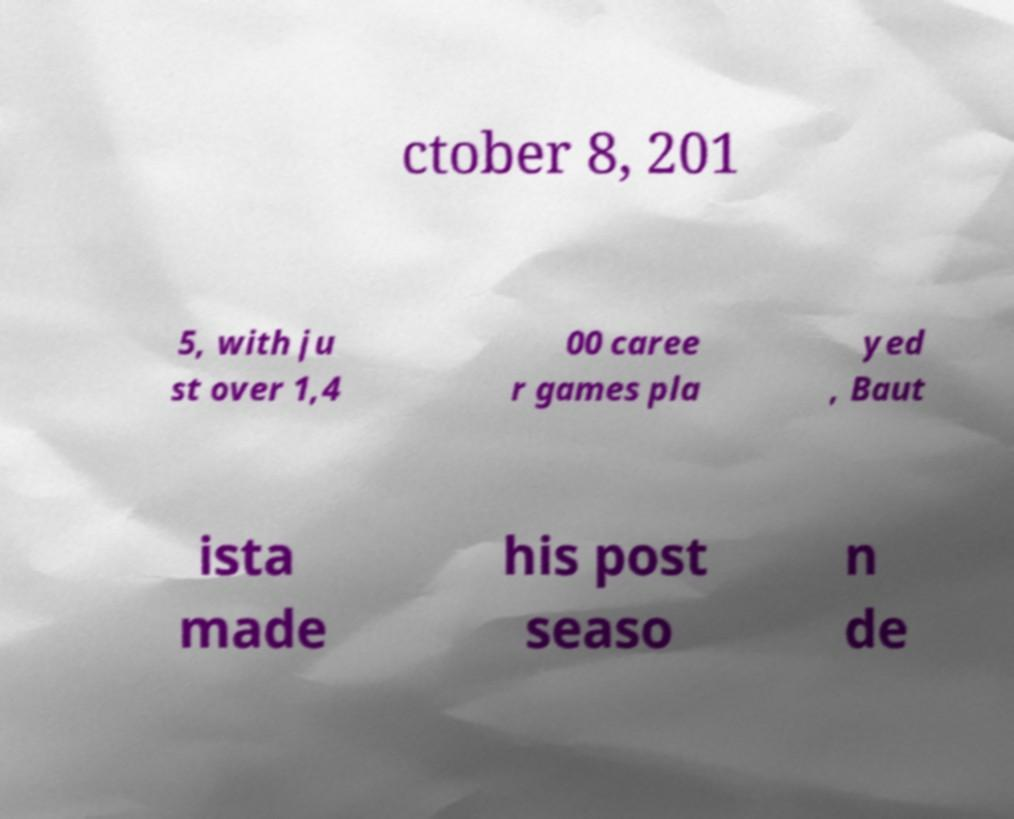I need the written content from this picture converted into text. Can you do that? ctober 8, 201 5, with ju st over 1,4 00 caree r games pla yed , Baut ista made his post seaso n de 